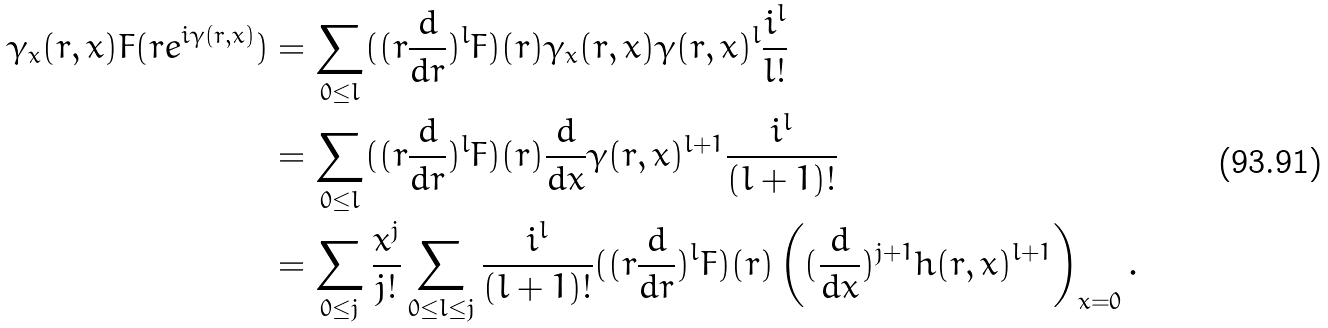<formula> <loc_0><loc_0><loc_500><loc_500>\gamma _ { x } ( r , x ) F ( r e ^ { i \gamma ( r , x ) } ) & = \sum _ { 0 \leq l } ( ( r \frac { d } { d r } ) ^ { l } F ) ( r ) \gamma _ { x } ( r , x ) \gamma ( r , x ) ^ { l } \frac { i ^ { l } } { l ! } \\ & = \sum _ { 0 \leq l } ( ( r \frac { d } { d r } ) ^ { l } F ) ( r ) \frac { d } { d x } \gamma ( r , x ) ^ { l + 1 } \frac { i ^ { l } } { ( l + 1 ) ! } \\ & = \sum _ { 0 \leq j } \frac { x ^ { j } } { j ! } \sum _ { 0 \leq l \leq j } \frac { i ^ { l } } { ( l + 1 ) ! } ( ( r \frac { d } { d r } ) ^ { l } F ) ( r ) \left ( ( \frac { d } { d x } ) ^ { j + 1 } h ( r , x ) ^ { l + 1 } \right ) _ { x = 0 } .</formula> 